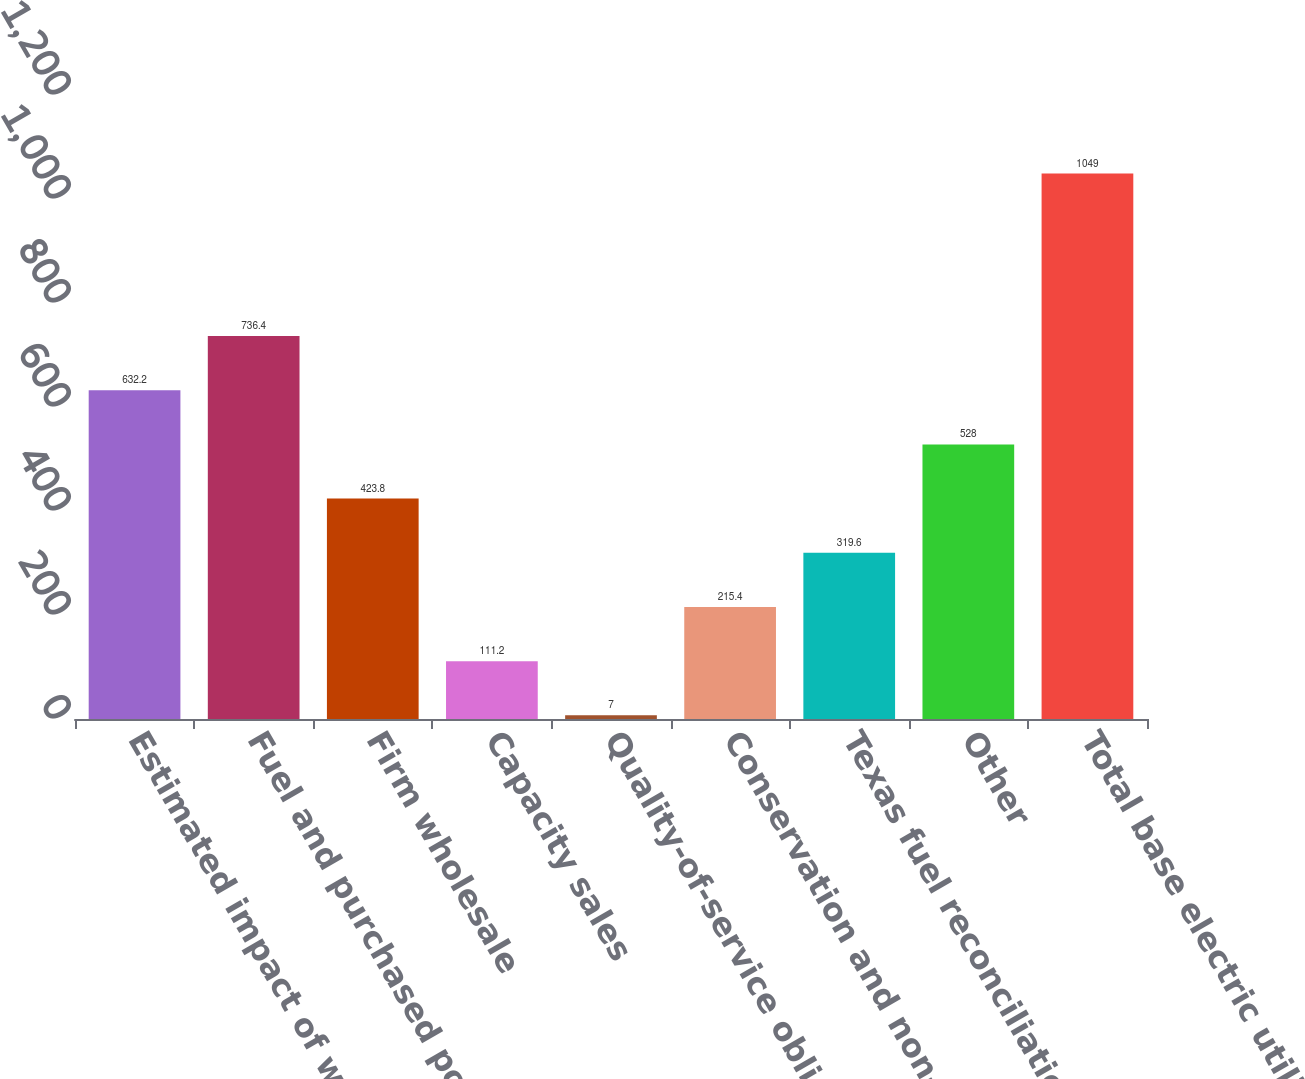Convert chart to OTSL. <chart><loc_0><loc_0><loc_500><loc_500><bar_chart><fcel>Estimated impact of weather<fcel>Fuel and purchased power cost<fcel>Firm wholesale<fcel>Capacity sales<fcel>Quality-of-service obligations<fcel>Conservation and non-fuel<fcel>Texas fuel reconciliation<fcel>Other<fcel>Total base electric utility<nl><fcel>632.2<fcel>736.4<fcel>423.8<fcel>111.2<fcel>7<fcel>215.4<fcel>319.6<fcel>528<fcel>1049<nl></chart> 